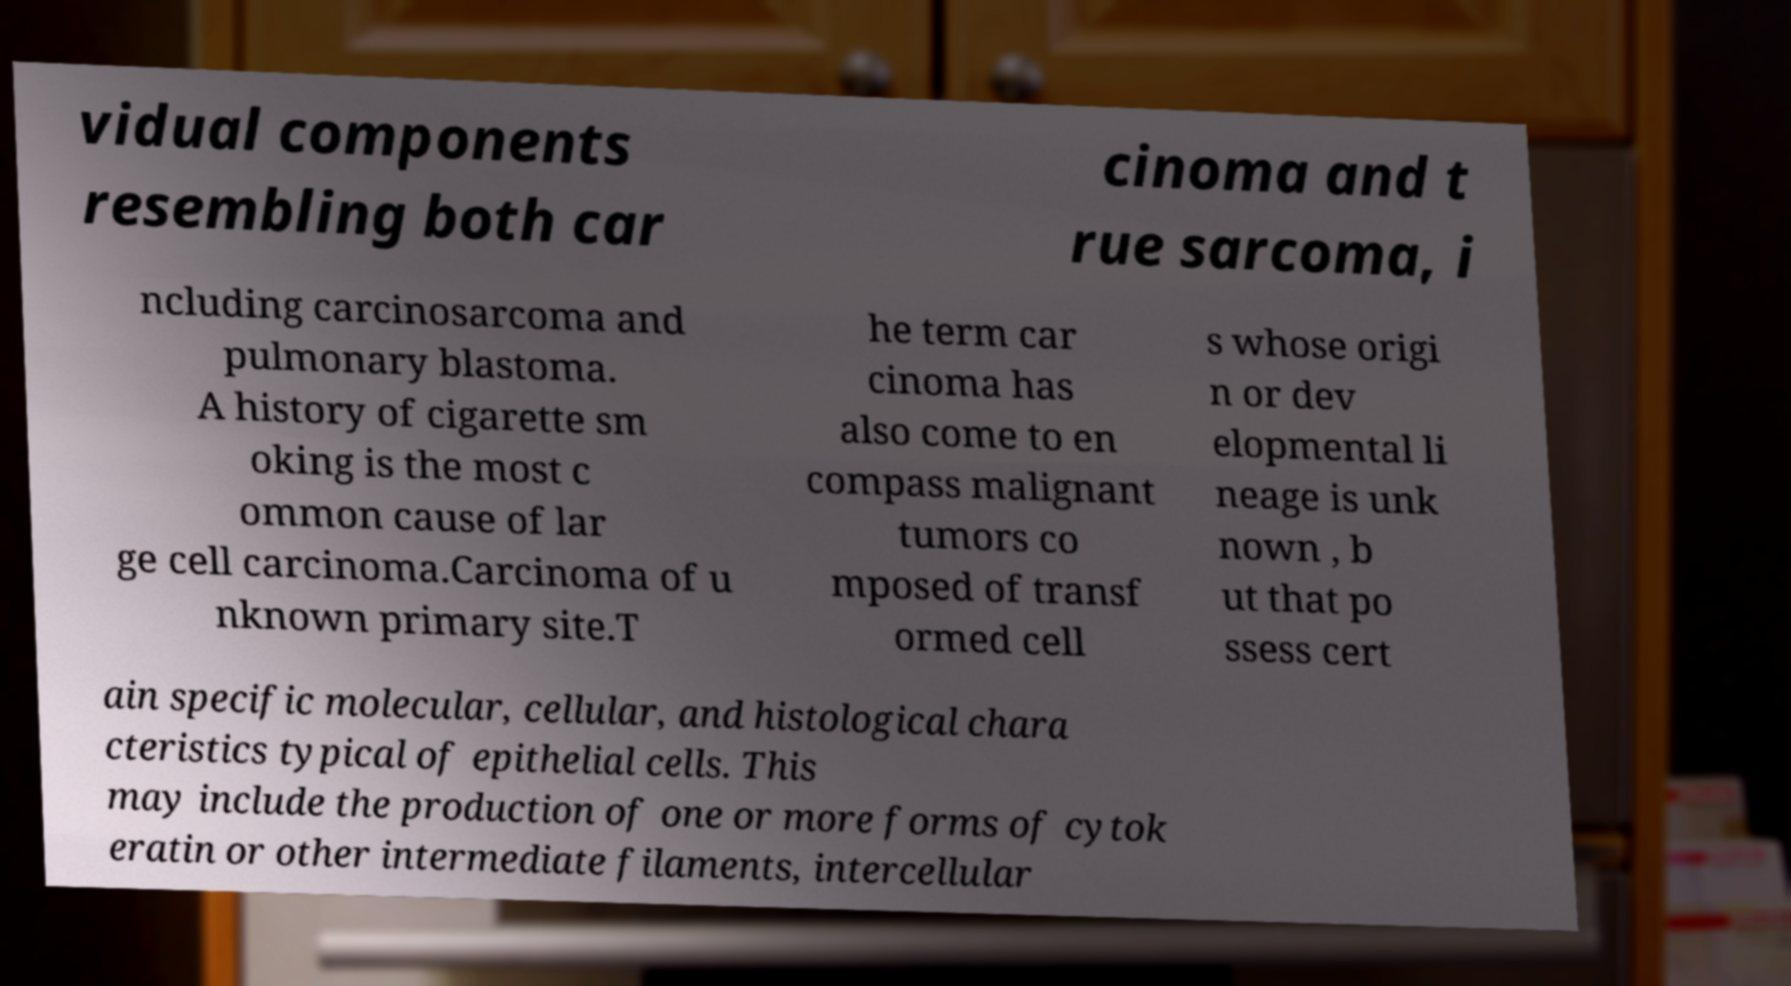Please identify and transcribe the text found in this image. vidual components resembling both car cinoma and t rue sarcoma, i ncluding carcinosarcoma and pulmonary blastoma. A history of cigarette sm oking is the most c ommon cause of lar ge cell carcinoma.Carcinoma of u nknown primary site.T he term car cinoma has also come to en compass malignant tumors co mposed of transf ormed cell s whose origi n or dev elopmental li neage is unk nown , b ut that po ssess cert ain specific molecular, cellular, and histological chara cteristics typical of epithelial cells. This may include the production of one or more forms of cytok eratin or other intermediate filaments, intercellular 